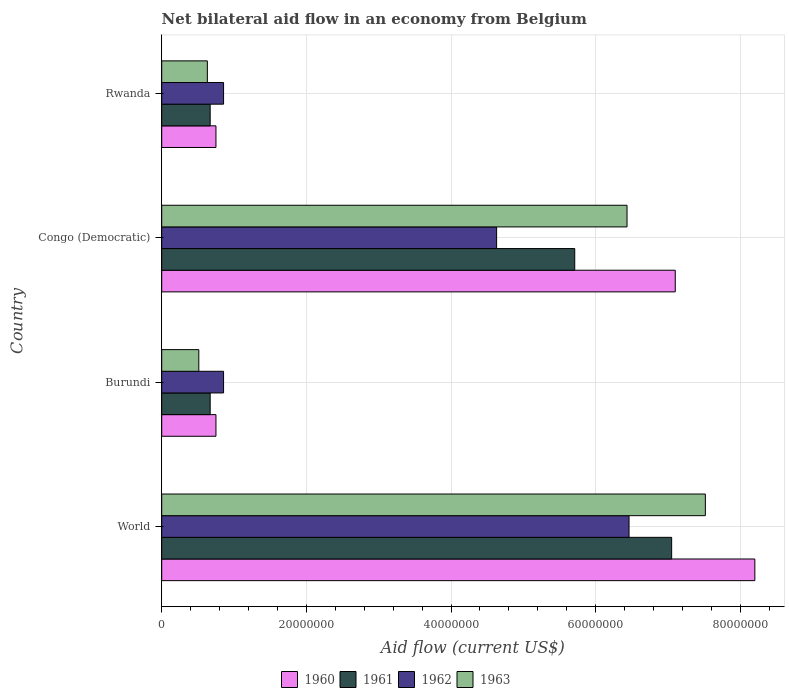Are the number of bars on each tick of the Y-axis equal?
Keep it short and to the point. Yes. How many bars are there on the 1st tick from the bottom?
Provide a short and direct response. 4. What is the label of the 4th group of bars from the top?
Your answer should be compact. World. In how many cases, is the number of bars for a given country not equal to the number of legend labels?
Provide a succinct answer. 0. What is the net bilateral aid flow in 1960 in Congo (Democratic)?
Keep it short and to the point. 7.10e+07. Across all countries, what is the maximum net bilateral aid flow in 1961?
Your answer should be very brief. 7.05e+07. Across all countries, what is the minimum net bilateral aid flow in 1962?
Provide a succinct answer. 8.55e+06. In which country was the net bilateral aid flow in 1963 maximum?
Provide a succinct answer. World. In which country was the net bilateral aid flow in 1963 minimum?
Keep it short and to the point. Burundi. What is the total net bilateral aid flow in 1962 in the graph?
Your answer should be very brief. 1.28e+08. What is the difference between the net bilateral aid flow in 1961 in Burundi and that in Congo (Democratic)?
Your answer should be very brief. -5.04e+07. What is the difference between the net bilateral aid flow in 1961 in Rwanda and the net bilateral aid flow in 1963 in World?
Provide a succinct answer. -6.85e+07. What is the average net bilateral aid flow in 1962 per country?
Your answer should be very brief. 3.20e+07. What is the difference between the net bilateral aid flow in 1960 and net bilateral aid flow in 1963 in Burundi?
Offer a terse response. 2.37e+06. What is the ratio of the net bilateral aid flow in 1960 in Rwanda to that in World?
Keep it short and to the point. 0.09. Is the difference between the net bilateral aid flow in 1960 in Burundi and Rwanda greater than the difference between the net bilateral aid flow in 1963 in Burundi and Rwanda?
Keep it short and to the point. Yes. What is the difference between the highest and the second highest net bilateral aid flow in 1962?
Your response must be concise. 1.83e+07. What is the difference between the highest and the lowest net bilateral aid flow in 1962?
Give a very brief answer. 5.61e+07. What does the 4th bar from the bottom in World represents?
Your answer should be very brief. 1963. Is it the case that in every country, the sum of the net bilateral aid flow in 1961 and net bilateral aid flow in 1960 is greater than the net bilateral aid flow in 1962?
Your answer should be compact. Yes. How many countries are there in the graph?
Your response must be concise. 4. Are the values on the major ticks of X-axis written in scientific E-notation?
Offer a terse response. No. Does the graph contain any zero values?
Offer a terse response. No. How are the legend labels stacked?
Keep it short and to the point. Horizontal. What is the title of the graph?
Offer a very short reply. Net bilateral aid flow in an economy from Belgium. What is the label or title of the Y-axis?
Provide a short and direct response. Country. What is the Aid flow (current US$) of 1960 in World?
Offer a terse response. 8.20e+07. What is the Aid flow (current US$) of 1961 in World?
Give a very brief answer. 7.05e+07. What is the Aid flow (current US$) in 1962 in World?
Make the answer very short. 6.46e+07. What is the Aid flow (current US$) of 1963 in World?
Your answer should be very brief. 7.52e+07. What is the Aid flow (current US$) in 1960 in Burundi?
Offer a terse response. 7.50e+06. What is the Aid flow (current US$) in 1961 in Burundi?
Provide a succinct answer. 6.70e+06. What is the Aid flow (current US$) of 1962 in Burundi?
Keep it short and to the point. 8.55e+06. What is the Aid flow (current US$) in 1963 in Burundi?
Your answer should be compact. 5.13e+06. What is the Aid flow (current US$) in 1960 in Congo (Democratic)?
Provide a succinct answer. 7.10e+07. What is the Aid flow (current US$) of 1961 in Congo (Democratic)?
Offer a terse response. 5.71e+07. What is the Aid flow (current US$) in 1962 in Congo (Democratic)?
Your response must be concise. 4.63e+07. What is the Aid flow (current US$) in 1963 in Congo (Democratic)?
Offer a terse response. 6.43e+07. What is the Aid flow (current US$) of 1960 in Rwanda?
Provide a succinct answer. 7.50e+06. What is the Aid flow (current US$) of 1961 in Rwanda?
Your response must be concise. 6.70e+06. What is the Aid flow (current US$) in 1962 in Rwanda?
Offer a very short reply. 8.55e+06. What is the Aid flow (current US$) in 1963 in Rwanda?
Provide a succinct answer. 6.31e+06. Across all countries, what is the maximum Aid flow (current US$) of 1960?
Offer a terse response. 8.20e+07. Across all countries, what is the maximum Aid flow (current US$) of 1961?
Give a very brief answer. 7.05e+07. Across all countries, what is the maximum Aid flow (current US$) of 1962?
Keep it short and to the point. 6.46e+07. Across all countries, what is the maximum Aid flow (current US$) in 1963?
Keep it short and to the point. 7.52e+07. Across all countries, what is the minimum Aid flow (current US$) in 1960?
Provide a succinct answer. 7.50e+06. Across all countries, what is the minimum Aid flow (current US$) of 1961?
Ensure brevity in your answer.  6.70e+06. Across all countries, what is the minimum Aid flow (current US$) in 1962?
Keep it short and to the point. 8.55e+06. Across all countries, what is the minimum Aid flow (current US$) in 1963?
Provide a short and direct response. 5.13e+06. What is the total Aid flow (current US$) in 1960 in the graph?
Provide a succinct answer. 1.68e+08. What is the total Aid flow (current US$) in 1961 in the graph?
Your response must be concise. 1.41e+08. What is the total Aid flow (current US$) of 1962 in the graph?
Your answer should be very brief. 1.28e+08. What is the total Aid flow (current US$) of 1963 in the graph?
Your answer should be compact. 1.51e+08. What is the difference between the Aid flow (current US$) in 1960 in World and that in Burundi?
Provide a short and direct response. 7.45e+07. What is the difference between the Aid flow (current US$) in 1961 in World and that in Burundi?
Make the answer very short. 6.38e+07. What is the difference between the Aid flow (current US$) of 1962 in World and that in Burundi?
Give a very brief answer. 5.61e+07. What is the difference between the Aid flow (current US$) in 1963 in World and that in Burundi?
Your answer should be compact. 7.00e+07. What is the difference between the Aid flow (current US$) of 1960 in World and that in Congo (Democratic)?
Offer a terse response. 1.10e+07. What is the difference between the Aid flow (current US$) in 1961 in World and that in Congo (Democratic)?
Ensure brevity in your answer.  1.34e+07. What is the difference between the Aid flow (current US$) in 1962 in World and that in Congo (Democratic)?
Ensure brevity in your answer.  1.83e+07. What is the difference between the Aid flow (current US$) in 1963 in World and that in Congo (Democratic)?
Your answer should be very brief. 1.08e+07. What is the difference between the Aid flow (current US$) in 1960 in World and that in Rwanda?
Give a very brief answer. 7.45e+07. What is the difference between the Aid flow (current US$) in 1961 in World and that in Rwanda?
Offer a very short reply. 6.38e+07. What is the difference between the Aid flow (current US$) in 1962 in World and that in Rwanda?
Ensure brevity in your answer.  5.61e+07. What is the difference between the Aid flow (current US$) in 1963 in World and that in Rwanda?
Offer a very short reply. 6.88e+07. What is the difference between the Aid flow (current US$) of 1960 in Burundi and that in Congo (Democratic)?
Provide a succinct answer. -6.35e+07. What is the difference between the Aid flow (current US$) in 1961 in Burundi and that in Congo (Democratic)?
Give a very brief answer. -5.04e+07. What is the difference between the Aid flow (current US$) in 1962 in Burundi and that in Congo (Democratic)?
Make the answer very short. -3.78e+07. What is the difference between the Aid flow (current US$) in 1963 in Burundi and that in Congo (Democratic)?
Keep it short and to the point. -5.92e+07. What is the difference between the Aid flow (current US$) of 1960 in Burundi and that in Rwanda?
Provide a short and direct response. 0. What is the difference between the Aid flow (current US$) of 1961 in Burundi and that in Rwanda?
Ensure brevity in your answer.  0. What is the difference between the Aid flow (current US$) of 1963 in Burundi and that in Rwanda?
Your response must be concise. -1.18e+06. What is the difference between the Aid flow (current US$) of 1960 in Congo (Democratic) and that in Rwanda?
Offer a very short reply. 6.35e+07. What is the difference between the Aid flow (current US$) of 1961 in Congo (Democratic) and that in Rwanda?
Ensure brevity in your answer.  5.04e+07. What is the difference between the Aid flow (current US$) in 1962 in Congo (Democratic) and that in Rwanda?
Provide a succinct answer. 3.78e+07. What is the difference between the Aid flow (current US$) in 1963 in Congo (Democratic) and that in Rwanda?
Offer a terse response. 5.80e+07. What is the difference between the Aid flow (current US$) of 1960 in World and the Aid flow (current US$) of 1961 in Burundi?
Your response must be concise. 7.53e+07. What is the difference between the Aid flow (current US$) of 1960 in World and the Aid flow (current US$) of 1962 in Burundi?
Offer a terse response. 7.34e+07. What is the difference between the Aid flow (current US$) in 1960 in World and the Aid flow (current US$) in 1963 in Burundi?
Keep it short and to the point. 7.69e+07. What is the difference between the Aid flow (current US$) of 1961 in World and the Aid flow (current US$) of 1962 in Burundi?
Provide a short and direct response. 6.20e+07. What is the difference between the Aid flow (current US$) in 1961 in World and the Aid flow (current US$) in 1963 in Burundi?
Provide a succinct answer. 6.54e+07. What is the difference between the Aid flow (current US$) of 1962 in World and the Aid flow (current US$) of 1963 in Burundi?
Your response must be concise. 5.95e+07. What is the difference between the Aid flow (current US$) of 1960 in World and the Aid flow (current US$) of 1961 in Congo (Democratic)?
Your response must be concise. 2.49e+07. What is the difference between the Aid flow (current US$) of 1960 in World and the Aid flow (current US$) of 1962 in Congo (Democratic)?
Your answer should be very brief. 3.57e+07. What is the difference between the Aid flow (current US$) in 1960 in World and the Aid flow (current US$) in 1963 in Congo (Democratic)?
Provide a short and direct response. 1.77e+07. What is the difference between the Aid flow (current US$) of 1961 in World and the Aid flow (current US$) of 1962 in Congo (Democratic)?
Your answer should be very brief. 2.42e+07. What is the difference between the Aid flow (current US$) of 1961 in World and the Aid flow (current US$) of 1963 in Congo (Democratic)?
Offer a terse response. 6.17e+06. What is the difference between the Aid flow (current US$) in 1960 in World and the Aid flow (current US$) in 1961 in Rwanda?
Your answer should be very brief. 7.53e+07. What is the difference between the Aid flow (current US$) in 1960 in World and the Aid flow (current US$) in 1962 in Rwanda?
Ensure brevity in your answer.  7.34e+07. What is the difference between the Aid flow (current US$) in 1960 in World and the Aid flow (current US$) in 1963 in Rwanda?
Make the answer very short. 7.57e+07. What is the difference between the Aid flow (current US$) of 1961 in World and the Aid flow (current US$) of 1962 in Rwanda?
Your answer should be compact. 6.20e+07. What is the difference between the Aid flow (current US$) of 1961 in World and the Aid flow (current US$) of 1963 in Rwanda?
Offer a terse response. 6.42e+07. What is the difference between the Aid flow (current US$) in 1962 in World and the Aid flow (current US$) in 1963 in Rwanda?
Offer a very short reply. 5.83e+07. What is the difference between the Aid flow (current US$) of 1960 in Burundi and the Aid flow (current US$) of 1961 in Congo (Democratic)?
Your answer should be compact. -4.96e+07. What is the difference between the Aid flow (current US$) in 1960 in Burundi and the Aid flow (current US$) in 1962 in Congo (Democratic)?
Your answer should be very brief. -3.88e+07. What is the difference between the Aid flow (current US$) of 1960 in Burundi and the Aid flow (current US$) of 1963 in Congo (Democratic)?
Your answer should be very brief. -5.68e+07. What is the difference between the Aid flow (current US$) of 1961 in Burundi and the Aid flow (current US$) of 1962 in Congo (Democratic)?
Offer a very short reply. -3.96e+07. What is the difference between the Aid flow (current US$) in 1961 in Burundi and the Aid flow (current US$) in 1963 in Congo (Democratic)?
Your answer should be compact. -5.76e+07. What is the difference between the Aid flow (current US$) of 1962 in Burundi and the Aid flow (current US$) of 1963 in Congo (Democratic)?
Keep it short and to the point. -5.58e+07. What is the difference between the Aid flow (current US$) in 1960 in Burundi and the Aid flow (current US$) in 1961 in Rwanda?
Offer a very short reply. 8.00e+05. What is the difference between the Aid flow (current US$) of 1960 in Burundi and the Aid flow (current US$) of 1962 in Rwanda?
Provide a short and direct response. -1.05e+06. What is the difference between the Aid flow (current US$) of 1960 in Burundi and the Aid flow (current US$) of 1963 in Rwanda?
Make the answer very short. 1.19e+06. What is the difference between the Aid flow (current US$) of 1961 in Burundi and the Aid flow (current US$) of 1962 in Rwanda?
Offer a terse response. -1.85e+06. What is the difference between the Aid flow (current US$) of 1961 in Burundi and the Aid flow (current US$) of 1963 in Rwanda?
Keep it short and to the point. 3.90e+05. What is the difference between the Aid flow (current US$) of 1962 in Burundi and the Aid flow (current US$) of 1963 in Rwanda?
Offer a terse response. 2.24e+06. What is the difference between the Aid flow (current US$) of 1960 in Congo (Democratic) and the Aid flow (current US$) of 1961 in Rwanda?
Offer a very short reply. 6.43e+07. What is the difference between the Aid flow (current US$) in 1960 in Congo (Democratic) and the Aid flow (current US$) in 1962 in Rwanda?
Provide a short and direct response. 6.24e+07. What is the difference between the Aid flow (current US$) of 1960 in Congo (Democratic) and the Aid flow (current US$) of 1963 in Rwanda?
Ensure brevity in your answer.  6.47e+07. What is the difference between the Aid flow (current US$) of 1961 in Congo (Democratic) and the Aid flow (current US$) of 1962 in Rwanda?
Provide a short and direct response. 4.86e+07. What is the difference between the Aid flow (current US$) of 1961 in Congo (Democratic) and the Aid flow (current US$) of 1963 in Rwanda?
Ensure brevity in your answer.  5.08e+07. What is the difference between the Aid flow (current US$) of 1962 in Congo (Democratic) and the Aid flow (current US$) of 1963 in Rwanda?
Offer a very short reply. 4.00e+07. What is the average Aid flow (current US$) in 1960 per country?
Offer a terse response. 4.20e+07. What is the average Aid flow (current US$) in 1961 per country?
Offer a terse response. 3.52e+07. What is the average Aid flow (current US$) of 1962 per country?
Provide a short and direct response. 3.20e+07. What is the average Aid flow (current US$) of 1963 per country?
Keep it short and to the point. 3.77e+07. What is the difference between the Aid flow (current US$) of 1960 and Aid flow (current US$) of 1961 in World?
Provide a short and direct response. 1.15e+07. What is the difference between the Aid flow (current US$) in 1960 and Aid flow (current US$) in 1962 in World?
Make the answer very short. 1.74e+07. What is the difference between the Aid flow (current US$) of 1960 and Aid flow (current US$) of 1963 in World?
Give a very brief answer. 6.84e+06. What is the difference between the Aid flow (current US$) of 1961 and Aid flow (current US$) of 1962 in World?
Provide a succinct answer. 5.89e+06. What is the difference between the Aid flow (current US$) in 1961 and Aid flow (current US$) in 1963 in World?
Offer a terse response. -4.66e+06. What is the difference between the Aid flow (current US$) in 1962 and Aid flow (current US$) in 1963 in World?
Your answer should be very brief. -1.06e+07. What is the difference between the Aid flow (current US$) of 1960 and Aid flow (current US$) of 1962 in Burundi?
Offer a very short reply. -1.05e+06. What is the difference between the Aid flow (current US$) of 1960 and Aid flow (current US$) of 1963 in Burundi?
Provide a succinct answer. 2.37e+06. What is the difference between the Aid flow (current US$) of 1961 and Aid flow (current US$) of 1962 in Burundi?
Provide a short and direct response. -1.85e+06. What is the difference between the Aid flow (current US$) in 1961 and Aid flow (current US$) in 1963 in Burundi?
Offer a terse response. 1.57e+06. What is the difference between the Aid flow (current US$) of 1962 and Aid flow (current US$) of 1963 in Burundi?
Provide a succinct answer. 3.42e+06. What is the difference between the Aid flow (current US$) in 1960 and Aid flow (current US$) in 1961 in Congo (Democratic)?
Ensure brevity in your answer.  1.39e+07. What is the difference between the Aid flow (current US$) in 1960 and Aid flow (current US$) in 1962 in Congo (Democratic)?
Give a very brief answer. 2.47e+07. What is the difference between the Aid flow (current US$) in 1960 and Aid flow (current US$) in 1963 in Congo (Democratic)?
Provide a succinct answer. 6.67e+06. What is the difference between the Aid flow (current US$) of 1961 and Aid flow (current US$) of 1962 in Congo (Democratic)?
Offer a very short reply. 1.08e+07. What is the difference between the Aid flow (current US$) of 1961 and Aid flow (current US$) of 1963 in Congo (Democratic)?
Give a very brief answer. -7.23e+06. What is the difference between the Aid flow (current US$) in 1962 and Aid flow (current US$) in 1963 in Congo (Democratic)?
Provide a succinct answer. -1.80e+07. What is the difference between the Aid flow (current US$) of 1960 and Aid flow (current US$) of 1962 in Rwanda?
Provide a succinct answer. -1.05e+06. What is the difference between the Aid flow (current US$) of 1960 and Aid flow (current US$) of 1963 in Rwanda?
Keep it short and to the point. 1.19e+06. What is the difference between the Aid flow (current US$) of 1961 and Aid flow (current US$) of 1962 in Rwanda?
Give a very brief answer. -1.85e+06. What is the difference between the Aid flow (current US$) in 1961 and Aid flow (current US$) in 1963 in Rwanda?
Provide a succinct answer. 3.90e+05. What is the difference between the Aid flow (current US$) in 1962 and Aid flow (current US$) in 1963 in Rwanda?
Your answer should be very brief. 2.24e+06. What is the ratio of the Aid flow (current US$) of 1960 in World to that in Burundi?
Keep it short and to the point. 10.93. What is the ratio of the Aid flow (current US$) of 1961 in World to that in Burundi?
Provide a short and direct response. 10.52. What is the ratio of the Aid flow (current US$) in 1962 in World to that in Burundi?
Provide a succinct answer. 7.56. What is the ratio of the Aid flow (current US$) in 1963 in World to that in Burundi?
Provide a short and direct response. 14.65. What is the ratio of the Aid flow (current US$) of 1960 in World to that in Congo (Democratic)?
Give a very brief answer. 1.15. What is the ratio of the Aid flow (current US$) in 1961 in World to that in Congo (Democratic)?
Give a very brief answer. 1.23. What is the ratio of the Aid flow (current US$) in 1962 in World to that in Congo (Democratic)?
Give a very brief answer. 1.4. What is the ratio of the Aid flow (current US$) of 1963 in World to that in Congo (Democratic)?
Give a very brief answer. 1.17. What is the ratio of the Aid flow (current US$) of 1960 in World to that in Rwanda?
Ensure brevity in your answer.  10.93. What is the ratio of the Aid flow (current US$) of 1961 in World to that in Rwanda?
Keep it short and to the point. 10.52. What is the ratio of the Aid flow (current US$) of 1962 in World to that in Rwanda?
Keep it short and to the point. 7.56. What is the ratio of the Aid flow (current US$) of 1963 in World to that in Rwanda?
Provide a short and direct response. 11.91. What is the ratio of the Aid flow (current US$) in 1960 in Burundi to that in Congo (Democratic)?
Give a very brief answer. 0.11. What is the ratio of the Aid flow (current US$) of 1961 in Burundi to that in Congo (Democratic)?
Your response must be concise. 0.12. What is the ratio of the Aid flow (current US$) of 1962 in Burundi to that in Congo (Democratic)?
Make the answer very short. 0.18. What is the ratio of the Aid flow (current US$) in 1963 in Burundi to that in Congo (Democratic)?
Your answer should be very brief. 0.08. What is the ratio of the Aid flow (current US$) of 1960 in Burundi to that in Rwanda?
Make the answer very short. 1. What is the ratio of the Aid flow (current US$) of 1961 in Burundi to that in Rwanda?
Your answer should be very brief. 1. What is the ratio of the Aid flow (current US$) of 1963 in Burundi to that in Rwanda?
Your answer should be very brief. 0.81. What is the ratio of the Aid flow (current US$) in 1960 in Congo (Democratic) to that in Rwanda?
Ensure brevity in your answer.  9.47. What is the ratio of the Aid flow (current US$) of 1961 in Congo (Democratic) to that in Rwanda?
Your response must be concise. 8.52. What is the ratio of the Aid flow (current US$) in 1962 in Congo (Democratic) to that in Rwanda?
Provide a succinct answer. 5.42. What is the ratio of the Aid flow (current US$) of 1963 in Congo (Democratic) to that in Rwanda?
Offer a terse response. 10.19. What is the difference between the highest and the second highest Aid flow (current US$) of 1960?
Offer a very short reply. 1.10e+07. What is the difference between the highest and the second highest Aid flow (current US$) of 1961?
Give a very brief answer. 1.34e+07. What is the difference between the highest and the second highest Aid flow (current US$) in 1962?
Provide a succinct answer. 1.83e+07. What is the difference between the highest and the second highest Aid flow (current US$) in 1963?
Provide a succinct answer. 1.08e+07. What is the difference between the highest and the lowest Aid flow (current US$) in 1960?
Offer a terse response. 7.45e+07. What is the difference between the highest and the lowest Aid flow (current US$) in 1961?
Your answer should be very brief. 6.38e+07. What is the difference between the highest and the lowest Aid flow (current US$) of 1962?
Your answer should be very brief. 5.61e+07. What is the difference between the highest and the lowest Aid flow (current US$) of 1963?
Offer a very short reply. 7.00e+07. 